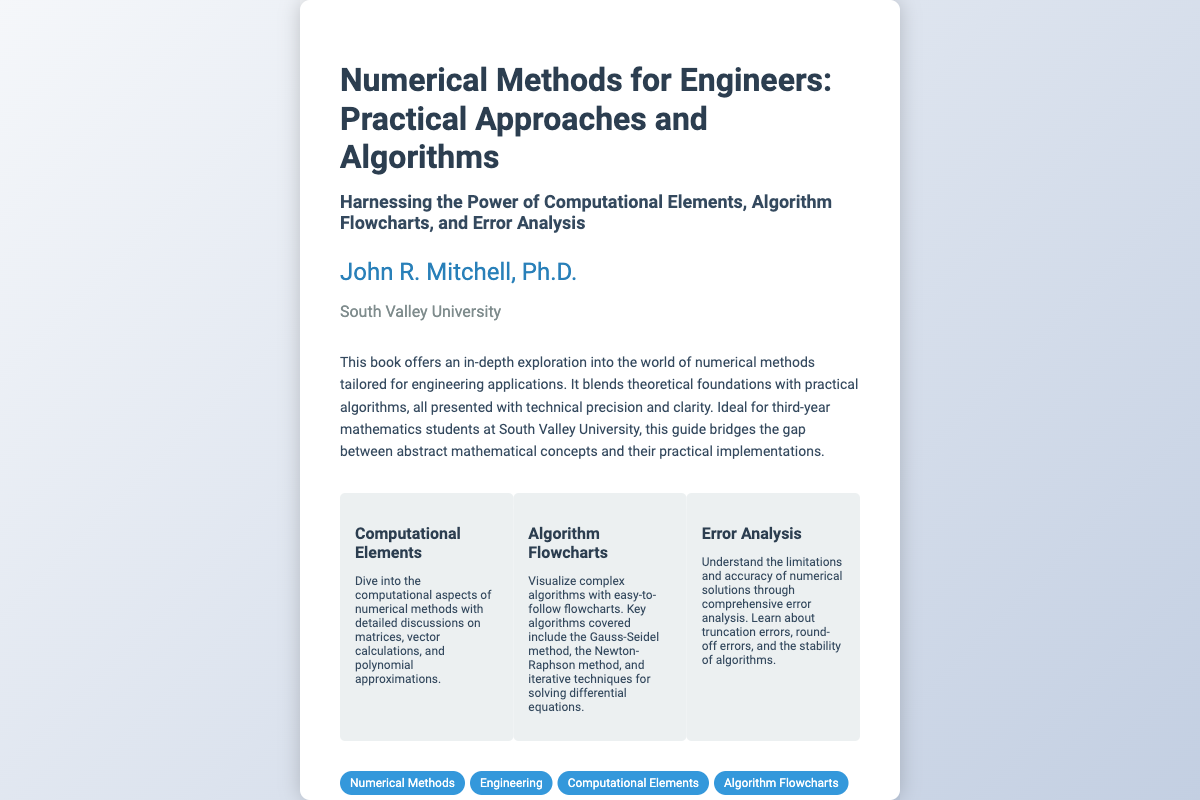What is the title of the book? The title is explicitly mentioned at the top of the document.
Answer: Numerical Methods for Engineers: Practical Approaches and Algorithms Who is the author of the book? The author's name is provided near the title of the document.
Answer: John R. Mitchell, Ph.D What year was the book published? The publication year can be found in the footer section of the document.
Answer: 2024 What university is associated with the author? The document clearly states the author's affiliation in a dedicated section.
Answer: South Valley University What method is mentioned under Algorithm Flowcharts? The document lists specific algorithms in the section about flowcharts.
Answer: Newton-Raphson method What are the three main sections highlighted in the book? The sections are mentioned in the content of the document.
Answer: Computational Elements, Algorithm Flowcharts, Error Analysis What type of analysis is discussed in the book? The description mentions a specific focus on one analytical aspect within numerical methods.
Answer: Error Analysis What does the description suggest the book is ideal for? The description specifies an audience that would benefit from the content.
Answer: third-year mathematics students 